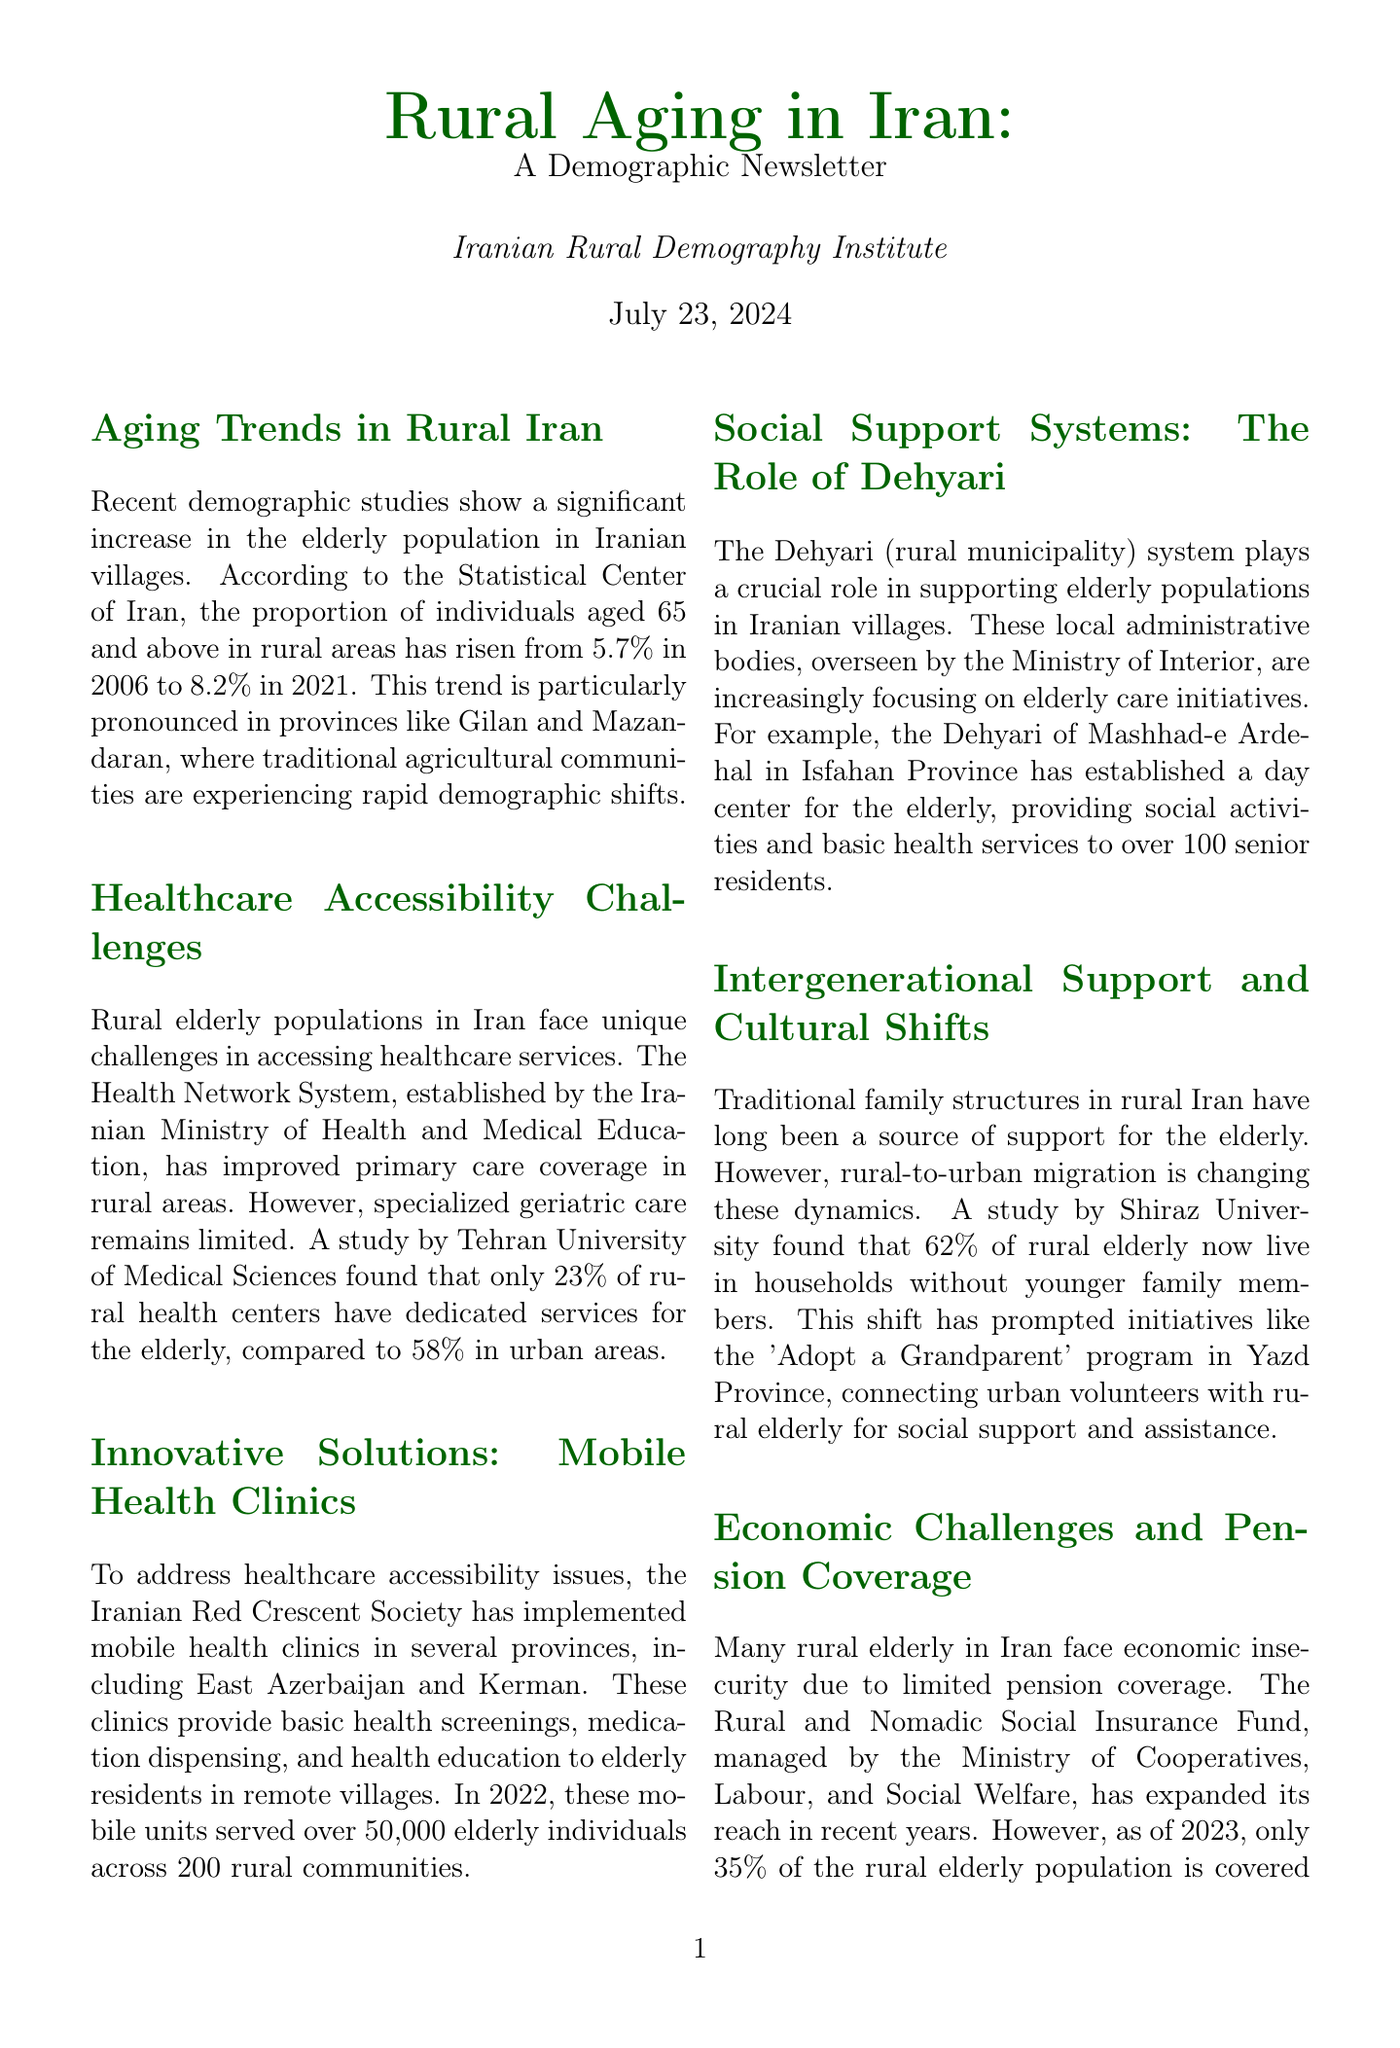what was the percentage of rural individuals aged 65 and above in 2006? The document states that the percentage of individuals aged 65 and above in rural areas was 5.7% in 2006.
Answer: 5.7% what is the percentage of rural health centers with dedicated services for the elderly? According to the study mentioned, only 23% of rural health centers have dedicated services for the elderly.
Answer: 23% which provinces are noted for significant aging trends in rural Iran? The document highlights Gilan and Mazandaran as provinces with pronounced aging trends.
Answer: Gilan and Mazandaran how many elderly individuals were served by mobile health clinics in 2022? The newsletter reports that mobile health clinics served over 50,000 elderly individuals in 2022.
Answer: 50,000 what is the role of Dehyari in supporting elderly populations? The Dehyari system plays a crucial role in supporting elderly populations in Iranian villages through care initiatives.
Answer: supporting elderly populations what program connects urban volunteers with rural elderly for social support? The 'Adopt a Grandparent' program connects urban volunteers with rural elderly for social support.
Answer: 'Adopt a Grandparent' program what percentage of the rural elderly population is covered by the Rural and Nomadic Social Insurance Fund as of 2023? As of 2023, only 35% of the rural elderly population is covered by this scheme.
Answer: 35% what is one of the recommendations for improving elderly care in rural Iran? One recommendation includes expanding telemedicine services to improve specialist care access.
Answer: expanding telemedicine services 